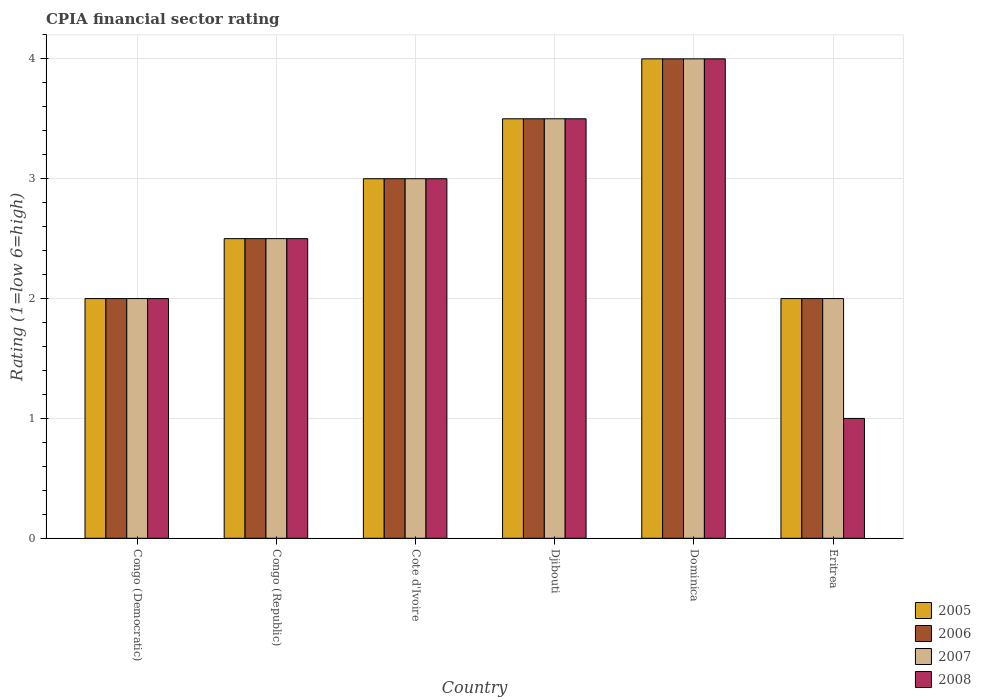How many groups of bars are there?
Your answer should be very brief. 6. Are the number of bars on each tick of the X-axis equal?
Keep it short and to the point. Yes. What is the label of the 6th group of bars from the left?
Your answer should be compact. Eritrea. Across all countries, what is the maximum CPIA rating in 2007?
Make the answer very short. 4. In which country was the CPIA rating in 2006 maximum?
Offer a terse response. Dominica. In which country was the CPIA rating in 2008 minimum?
Provide a succinct answer. Eritrea. What is the total CPIA rating in 2006 in the graph?
Give a very brief answer. 17. What is the difference between the CPIA rating in 2008 in Congo (Republic) and that in Djibouti?
Keep it short and to the point. -1. What is the difference between the CPIA rating in 2006 in Dominica and the CPIA rating in 2007 in Congo (Democratic)?
Your response must be concise. 2. What is the average CPIA rating in 2006 per country?
Offer a terse response. 2.83. In how many countries, is the CPIA rating in 2005 greater than 3.2?
Provide a short and direct response. 2. What is the difference between the highest and the lowest CPIA rating in 2005?
Ensure brevity in your answer.  2. In how many countries, is the CPIA rating in 2005 greater than the average CPIA rating in 2005 taken over all countries?
Offer a terse response. 3. Is the sum of the CPIA rating in 2005 in Congo (Democratic) and Djibouti greater than the maximum CPIA rating in 2007 across all countries?
Your response must be concise. Yes. Is it the case that in every country, the sum of the CPIA rating in 2008 and CPIA rating in 2007 is greater than the sum of CPIA rating in 2005 and CPIA rating in 2006?
Offer a terse response. No. What does the 4th bar from the left in Eritrea represents?
Your answer should be compact. 2008. How many bars are there?
Provide a short and direct response. 24. What is the difference between two consecutive major ticks on the Y-axis?
Provide a short and direct response. 1. Are the values on the major ticks of Y-axis written in scientific E-notation?
Keep it short and to the point. No. Does the graph contain any zero values?
Your response must be concise. No. What is the title of the graph?
Keep it short and to the point. CPIA financial sector rating. Does "1978" appear as one of the legend labels in the graph?
Your response must be concise. No. What is the label or title of the Y-axis?
Offer a terse response. Rating (1=low 6=high). What is the Rating (1=low 6=high) of 2005 in Congo (Democratic)?
Ensure brevity in your answer.  2. What is the Rating (1=low 6=high) of 2006 in Congo (Democratic)?
Offer a very short reply. 2. What is the Rating (1=low 6=high) in 2007 in Congo (Democratic)?
Offer a terse response. 2. What is the Rating (1=low 6=high) in 2008 in Congo (Democratic)?
Ensure brevity in your answer.  2. What is the Rating (1=low 6=high) of 2008 in Congo (Republic)?
Give a very brief answer. 2.5. What is the Rating (1=low 6=high) of 2006 in Cote d'Ivoire?
Give a very brief answer. 3. What is the Rating (1=low 6=high) of 2005 in Djibouti?
Offer a very short reply. 3.5. What is the Rating (1=low 6=high) of 2006 in Djibouti?
Make the answer very short. 3.5. What is the Rating (1=low 6=high) in 2005 in Dominica?
Make the answer very short. 4. What is the Rating (1=low 6=high) in 2006 in Dominica?
Keep it short and to the point. 4. What is the Rating (1=low 6=high) in 2007 in Dominica?
Your answer should be compact. 4. What is the Rating (1=low 6=high) in 2005 in Eritrea?
Give a very brief answer. 2. What is the Rating (1=low 6=high) in 2007 in Eritrea?
Ensure brevity in your answer.  2. Across all countries, what is the maximum Rating (1=low 6=high) of 2005?
Your answer should be compact. 4. Across all countries, what is the maximum Rating (1=low 6=high) in 2006?
Provide a short and direct response. 4. Across all countries, what is the maximum Rating (1=low 6=high) of 2007?
Your answer should be very brief. 4. Across all countries, what is the maximum Rating (1=low 6=high) of 2008?
Give a very brief answer. 4. Across all countries, what is the minimum Rating (1=low 6=high) of 2006?
Keep it short and to the point. 2. Across all countries, what is the minimum Rating (1=low 6=high) in 2008?
Your response must be concise. 1. What is the total Rating (1=low 6=high) of 2006 in the graph?
Your answer should be very brief. 17. What is the total Rating (1=low 6=high) in 2008 in the graph?
Your response must be concise. 16. What is the difference between the Rating (1=low 6=high) of 2005 in Congo (Democratic) and that in Congo (Republic)?
Your answer should be compact. -0.5. What is the difference between the Rating (1=low 6=high) of 2005 in Congo (Democratic) and that in Cote d'Ivoire?
Your answer should be very brief. -1. What is the difference between the Rating (1=low 6=high) of 2006 in Congo (Democratic) and that in Cote d'Ivoire?
Give a very brief answer. -1. What is the difference between the Rating (1=low 6=high) in 2008 in Congo (Democratic) and that in Djibouti?
Provide a short and direct response. -1.5. What is the difference between the Rating (1=low 6=high) in 2008 in Congo (Democratic) and that in Dominica?
Your answer should be very brief. -2. What is the difference between the Rating (1=low 6=high) of 2006 in Congo (Democratic) and that in Eritrea?
Ensure brevity in your answer.  0. What is the difference between the Rating (1=low 6=high) of 2008 in Congo (Democratic) and that in Eritrea?
Give a very brief answer. 1. What is the difference between the Rating (1=low 6=high) in 2005 in Congo (Republic) and that in Cote d'Ivoire?
Your answer should be very brief. -0.5. What is the difference between the Rating (1=low 6=high) in 2006 in Congo (Republic) and that in Cote d'Ivoire?
Your answer should be compact. -0.5. What is the difference between the Rating (1=low 6=high) in 2005 in Congo (Republic) and that in Djibouti?
Offer a terse response. -1. What is the difference between the Rating (1=low 6=high) in 2006 in Congo (Republic) and that in Djibouti?
Keep it short and to the point. -1. What is the difference between the Rating (1=low 6=high) of 2008 in Congo (Republic) and that in Djibouti?
Give a very brief answer. -1. What is the difference between the Rating (1=low 6=high) of 2007 in Congo (Republic) and that in Dominica?
Offer a very short reply. -1.5. What is the difference between the Rating (1=low 6=high) of 2005 in Congo (Republic) and that in Eritrea?
Give a very brief answer. 0.5. What is the difference between the Rating (1=low 6=high) in 2006 in Congo (Republic) and that in Eritrea?
Keep it short and to the point. 0.5. What is the difference between the Rating (1=low 6=high) in 2007 in Cote d'Ivoire and that in Djibouti?
Give a very brief answer. -0.5. What is the difference between the Rating (1=low 6=high) in 2008 in Cote d'Ivoire and that in Djibouti?
Keep it short and to the point. -0.5. What is the difference between the Rating (1=low 6=high) in 2006 in Cote d'Ivoire and that in Dominica?
Provide a short and direct response. -1. What is the difference between the Rating (1=low 6=high) of 2008 in Cote d'Ivoire and that in Eritrea?
Your answer should be compact. 2. What is the difference between the Rating (1=low 6=high) in 2006 in Djibouti and that in Dominica?
Ensure brevity in your answer.  -0.5. What is the difference between the Rating (1=low 6=high) in 2007 in Djibouti and that in Dominica?
Your answer should be very brief. -0.5. What is the difference between the Rating (1=low 6=high) in 2008 in Djibouti and that in Dominica?
Keep it short and to the point. -0.5. What is the difference between the Rating (1=low 6=high) in 2006 in Djibouti and that in Eritrea?
Your answer should be compact. 1.5. What is the difference between the Rating (1=low 6=high) in 2005 in Congo (Democratic) and the Rating (1=low 6=high) in 2006 in Congo (Republic)?
Your response must be concise. -0.5. What is the difference between the Rating (1=low 6=high) of 2005 in Congo (Democratic) and the Rating (1=low 6=high) of 2007 in Congo (Republic)?
Give a very brief answer. -0.5. What is the difference between the Rating (1=low 6=high) in 2005 in Congo (Democratic) and the Rating (1=low 6=high) in 2008 in Congo (Republic)?
Your answer should be compact. -0.5. What is the difference between the Rating (1=low 6=high) in 2006 in Congo (Democratic) and the Rating (1=low 6=high) in 2007 in Congo (Republic)?
Make the answer very short. -0.5. What is the difference between the Rating (1=low 6=high) in 2007 in Congo (Democratic) and the Rating (1=low 6=high) in 2008 in Congo (Republic)?
Keep it short and to the point. -0.5. What is the difference between the Rating (1=low 6=high) of 2005 in Congo (Democratic) and the Rating (1=low 6=high) of 2006 in Cote d'Ivoire?
Give a very brief answer. -1. What is the difference between the Rating (1=low 6=high) in 2005 in Congo (Democratic) and the Rating (1=low 6=high) in 2007 in Cote d'Ivoire?
Offer a very short reply. -1. What is the difference between the Rating (1=low 6=high) of 2005 in Congo (Democratic) and the Rating (1=low 6=high) of 2008 in Cote d'Ivoire?
Make the answer very short. -1. What is the difference between the Rating (1=low 6=high) in 2006 in Congo (Democratic) and the Rating (1=low 6=high) in 2007 in Cote d'Ivoire?
Give a very brief answer. -1. What is the difference between the Rating (1=low 6=high) of 2006 in Congo (Democratic) and the Rating (1=low 6=high) of 2008 in Cote d'Ivoire?
Offer a terse response. -1. What is the difference between the Rating (1=low 6=high) in 2005 in Congo (Democratic) and the Rating (1=low 6=high) in 2007 in Djibouti?
Keep it short and to the point. -1.5. What is the difference between the Rating (1=low 6=high) in 2006 in Congo (Democratic) and the Rating (1=low 6=high) in 2007 in Djibouti?
Offer a terse response. -1.5. What is the difference between the Rating (1=low 6=high) in 2007 in Congo (Democratic) and the Rating (1=low 6=high) in 2008 in Djibouti?
Make the answer very short. -1.5. What is the difference between the Rating (1=low 6=high) of 2005 in Congo (Democratic) and the Rating (1=low 6=high) of 2008 in Dominica?
Make the answer very short. -2. What is the difference between the Rating (1=low 6=high) of 2006 in Congo (Democratic) and the Rating (1=low 6=high) of 2007 in Dominica?
Offer a terse response. -2. What is the difference between the Rating (1=low 6=high) in 2007 in Congo (Democratic) and the Rating (1=low 6=high) in 2008 in Dominica?
Offer a very short reply. -2. What is the difference between the Rating (1=low 6=high) of 2005 in Congo (Democratic) and the Rating (1=low 6=high) of 2008 in Eritrea?
Provide a short and direct response. 1. What is the difference between the Rating (1=low 6=high) of 2007 in Congo (Democratic) and the Rating (1=low 6=high) of 2008 in Eritrea?
Provide a short and direct response. 1. What is the difference between the Rating (1=low 6=high) of 2005 in Congo (Republic) and the Rating (1=low 6=high) of 2006 in Cote d'Ivoire?
Your response must be concise. -0.5. What is the difference between the Rating (1=low 6=high) of 2005 in Congo (Republic) and the Rating (1=low 6=high) of 2007 in Cote d'Ivoire?
Keep it short and to the point. -0.5. What is the difference between the Rating (1=low 6=high) of 2005 in Congo (Republic) and the Rating (1=low 6=high) of 2008 in Cote d'Ivoire?
Provide a succinct answer. -0.5. What is the difference between the Rating (1=low 6=high) in 2006 in Congo (Republic) and the Rating (1=low 6=high) in 2008 in Cote d'Ivoire?
Offer a very short reply. -0.5. What is the difference between the Rating (1=low 6=high) in 2007 in Congo (Republic) and the Rating (1=low 6=high) in 2008 in Cote d'Ivoire?
Your response must be concise. -0.5. What is the difference between the Rating (1=low 6=high) of 2005 in Congo (Republic) and the Rating (1=low 6=high) of 2006 in Djibouti?
Ensure brevity in your answer.  -1. What is the difference between the Rating (1=low 6=high) of 2005 in Congo (Republic) and the Rating (1=low 6=high) of 2007 in Djibouti?
Offer a very short reply. -1. What is the difference between the Rating (1=low 6=high) of 2006 in Congo (Republic) and the Rating (1=low 6=high) of 2007 in Djibouti?
Your response must be concise. -1. What is the difference between the Rating (1=low 6=high) of 2006 in Congo (Republic) and the Rating (1=low 6=high) of 2008 in Djibouti?
Offer a very short reply. -1. What is the difference between the Rating (1=low 6=high) of 2007 in Congo (Republic) and the Rating (1=low 6=high) of 2008 in Djibouti?
Your answer should be compact. -1. What is the difference between the Rating (1=low 6=high) of 2005 in Congo (Republic) and the Rating (1=low 6=high) of 2006 in Dominica?
Your response must be concise. -1.5. What is the difference between the Rating (1=low 6=high) in 2005 in Congo (Republic) and the Rating (1=low 6=high) in 2007 in Dominica?
Offer a terse response. -1.5. What is the difference between the Rating (1=low 6=high) in 2005 in Congo (Republic) and the Rating (1=low 6=high) in 2008 in Dominica?
Your answer should be very brief. -1.5. What is the difference between the Rating (1=low 6=high) in 2006 in Congo (Republic) and the Rating (1=low 6=high) in 2007 in Dominica?
Give a very brief answer. -1.5. What is the difference between the Rating (1=low 6=high) of 2006 in Congo (Republic) and the Rating (1=low 6=high) of 2008 in Dominica?
Offer a terse response. -1.5. What is the difference between the Rating (1=low 6=high) of 2005 in Congo (Republic) and the Rating (1=low 6=high) of 2008 in Eritrea?
Your answer should be very brief. 1.5. What is the difference between the Rating (1=low 6=high) of 2006 in Congo (Republic) and the Rating (1=low 6=high) of 2007 in Eritrea?
Your answer should be compact. 0.5. What is the difference between the Rating (1=low 6=high) in 2005 in Cote d'Ivoire and the Rating (1=low 6=high) in 2006 in Djibouti?
Your answer should be compact. -0.5. What is the difference between the Rating (1=low 6=high) of 2005 in Cote d'Ivoire and the Rating (1=low 6=high) of 2007 in Djibouti?
Make the answer very short. -0.5. What is the difference between the Rating (1=low 6=high) in 2005 in Cote d'Ivoire and the Rating (1=low 6=high) in 2007 in Dominica?
Offer a terse response. -1. What is the difference between the Rating (1=low 6=high) in 2005 in Cote d'Ivoire and the Rating (1=low 6=high) in 2008 in Dominica?
Make the answer very short. -1. What is the difference between the Rating (1=low 6=high) of 2006 in Cote d'Ivoire and the Rating (1=low 6=high) of 2008 in Dominica?
Give a very brief answer. -1. What is the difference between the Rating (1=low 6=high) in 2005 in Cote d'Ivoire and the Rating (1=low 6=high) in 2006 in Eritrea?
Keep it short and to the point. 1. What is the difference between the Rating (1=low 6=high) in 2005 in Cote d'Ivoire and the Rating (1=low 6=high) in 2008 in Eritrea?
Offer a terse response. 2. What is the difference between the Rating (1=low 6=high) in 2006 in Cote d'Ivoire and the Rating (1=low 6=high) in 2007 in Eritrea?
Ensure brevity in your answer.  1. What is the difference between the Rating (1=low 6=high) in 2005 in Djibouti and the Rating (1=low 6=high) in 2007 in Dominica?
Offer a terse response. -0.5. What is the difference between the Rating (1=low 6=high) of 2005 in Djibouti and the Rating (1=low 6=high) of 2008 in Dominica?
Provide a succinct answer. -0.5. What is the difference between the Rating (1=low 6=high) of 2006 in Djibouti and the Rating (1=low 6=high) of 2007 in Dominica?
Give a very brief answer. -0.5. What is the difference between the Rating (1=low 6=high) of 2006 in Djibouti and the Rating (1=low 6=high) of 2008 in Dominica?
Your answer should be very brief. -0.5. What is the difference between the Rating (1=low 6=high) in 2007 in Djibouti and the Rating (1=low 6=high) in 2008 in Dominica?
Provide a succinct answer. -0.5. What is the difference between the Rating (1=low 6=high) in 2005 in Djibouti and the Rating (1=low 6=high) in 2008 in Eritrea?
Your response must be concise. 2.5. What is the difference between the Rating (1=low 6=high) in 2006 in Djibouti and the Rating (1=low 6=high) in 2008 in Eritrea?
Keep it short and to the point. 2.5. What is the difference between the Rating (1=low 6=high) of 2005 in Dominica and the Rating (1=low 6=high) of 2007 in Eritrea?
Make the answer very short. 2. What is the difference between the Rating (1=low 6=high) of 2006 in Dominica and the Rating (1=low 6=high) of 2007 in Eritrea?
Make the answer very short. 2. What is the average Rating (1=low 6=high) in 2005 per country?
Offer a terse response. 2.83. What is the average Rating (1=low 6=high) in 2006 per country?
Keep it short and to the point. 2.83. What is the average Rating (1=low 6=high) of 2007 per country?
Keep it short and to the point. 2.83. What is the average Rating (1=low 6=high) of 2008 per country?
Your answer should be very brief. 2.67. What is the difference between the Rating (1=low 6=high) of 2005 and Rating (1=low 6=high) of 2007 in Congo (Democratic)?
Your response must be concise. 0. What is the difference between the Rating (1=low 6=high) in 2006 and Rating (1=low 6=high) in 2007 in Congo (Democratic)?
Make the answer very short. 0. What is the difference between the Rating (1=low 6=high) of 2005 and Rating (1=low 6=high) of 2007 in Congo (Republic)?
Offer a very short reply. 0. What is the difference between the Rating (1=low 6=high) in 2005 and Rating (1=low 6=high) in 2008 in Cote d'Ivoire?
Your response must be concise. 0. What is the difference between the Rating (1=low 6=high) of 2006 and Rating (1=low 6=high) of 2007 in Cote d'Ivoire?
Keep it short and to the point. 0. What is the difference between the Rating (1=low 6=high) of 2006 and Rating (1=low 6=high) of 2008 in Cote d'Ivoire?
Offer a very short reply. 0. What is the difference between the Rating (1=low 6=high) of 2007 and Rating (1=low 6=high) of 2008 in Cote d'Ivoire?
Offer a terse response. 0. What is the difference between the Rating (1=low 6=high) of 2005 and Rating (1=low 6=high) of 2006 in Djibouti?
Offer a very short reply. 0. What is the difference between the Rating (1=low 6=high) of 2005 and Rating (1=low 6=high) of 2007 in Djibouti?
Provide a short and direct response. 0. What is the difference between the Rating (1=low 6=high) of 2006 and Rating (1=low 6=high) of 2008 in Djibouti?
Keep it short and to the point. 0. What is the difference between the Rating (1=low 6=high) in 2007 and Rating (1=low 6=high) in 2008 in Djibouti?
Provide a succinct answer. 0. What is the difference between the Rating (1=low 6=high) in 2005 and Rating (1=low 6=high) in 2006 in Dominica?
Give a very brief answer. 0. What is the difference between the Rating (1=low 6=high) of 2006 and Rating (1=low 6=high) of 2008 in Dominica?
Ensure brevity in your answer.  0. What is the difference between the Rating (1=low 6=high) in 2007 and Rating (1=low 6=high) in 2008 in Dominica?
Ensure brevity in your answer.  0. What is the difference between the Rating (1=low 6=high) of 2005 and Rating (1=low 6=high) of 2008 in Eritrea?
Ensure brevity in your answer.  1. What is the difference between the Rating (1=low 6=high) of 2006 and Rating (1=low 6=high) of 2007 in Eritrea?
Offer a terse response. 0. What is the ratio of the Rating (1=low 6=high) of 2005 in Congo (Democratic) to that in Congo (Republic)?
Provide a short and direct response. 0.8. What is the ratio of the Rating (1=low 6=high) in 2007 in Congo (Democratic) to that in Congo (Republic)?
Make the answer very short. 0.8. What is the ratio of the Rating (1=low 6=high) of 2008 in Congo (Democratic) to that in Congo (Republic)?
Offer a terse response. 0.8. What is the ratio of the Rating (1=low 6=high) of 2007 in Congo (Democratic) to that in Cote d'Ivoire?
Make the answer very short. 0.67. What is the ratio of the Rating (1=low 6=high) in 2008 in Congo (Democratic) to that in Cote d'Ivoire?
Your response must be concise. 0.67. What is the ratio of the Rating (1=low 6=high) in 2005 in Congo (Democratic) to that in Dominica?
Give a very brief answer. 0.5. What is the ratio of the Rating (1=low 6=high) in 2006 in Congo (Democratic) to that in Dominica?
Give a very brief answer. 0.5. What is the ratio of the Rating (1=low 6=high) of 2007 in Congo (Democratic) to that in Dominica?
Keep it short and to the point. 0.5. What is the ratio of the Rating (1=low 6=high) of 2008 in Congo (Democratic) to that in Dominica?
Your answer should be compact. 0.5. What is the ratio of the Rating (1=low 6=high) of 2006 in Congo (Democratic) to that in Eritrea?
Provide a short and direct response. 1. What is the ratio of the Rating (1=low 6=high) of 2007 in Congo (Democratic) to that in Eritrea?
Keep it short and to the point. 1. What is the ratio of the Rating (1=low 6=high) in 2008 in Congo (Democratic) to that in Eritrea?
Your answer should be compact. 2. What is the ratio of the Rating (1=low 6=high) of 2005 in Congo (Republic) to that in Djibouti?
Your answer should be very brief. 0.71. What is the ratio of the Rating (1=low 6=high) in 2006 in Congo (Republic) to that in Djibouti?
Your answer should be very brief. 0.71. What is the ratio of the Rating (1=low 6=high) of 2005 in Congo (Republic) to that in Dominica?
Ensure brevity in your answer.  0.62. What is the ratio of the Rating (1=low 6=high) in 2006 in Congo (Republic) to that in Dominica?
Your answer should be compact. 0.62. What is the ratio of the Rating (1=low 6=high) in 2007 in Congo (Republic) to that in Dominica?
Provide a succinct answer. 0.62. What is the ratio of the Rating (1=low 6=high) of 2008 in Congo (Republic) to that in Dominica?
Make the answer very short. 0.62. What is the ratio of the Rating (1=low 6=high) in 2005 in Congo (Republic) to that in Eritrea?
Make the answer very short. 1.25. What is the ratio of the Rating (1=low 6=high) of 2008 in Congo (Republic) to that in Eritrea?
Ensure brevity in your answer.  2.5. What is the ratio of the Rating (1=low 6=high) in 2006 in Cote d'Ivoire to that in Dominica?
Ensure brevity in your answer.  0.75. What is the ratio of the Rating (1=low 6=high) in 2007 in Cote d'Ivoire to that in Dominica?
Offer a terse response. 0.75. What is the ratio of the Rating (1=low 6=high) in 2008 in Cote d'Ivoire to that in Eritrea?
Offer a terse response. 3. What is the ratio of the Rating (1=low 6=high) in 2005 in Djibouti to that in Dominica?
Offer a very short reply. 0.88. What is the ratio of the Rating (1=low 6=high) of 2007 in Djibouti to that in Dominica?
Your answer should be very brief. 0.88. What is the ratio of the Rating (1=low 6=high) of 2008 in Djibouti to that in Dominica?
Keep it short and to the point. 0.88. What is the ratio of the Rating (1=low 6=high) of 2008 in Djibouti to that in Eritrea?
Keep it short and to the point. 3.5. What is the ratio of the Rating (1=low 6=high) in 2006 in Dominica to that in Eritrea?
Offer a very short reply. 2. What is the ratio of the Rating (1=low 6=high) in 2007 in Dominica to that in Eritrea?
Your answer should be very brief. 2. What is the difference between the highest and the second highest Rating (1=low 6=high) of 2005?
Your response must be concise. 0.5. What is the difference between the highest and the second highest Rating (1=low 6=high) of 2006?
Give a very brief answer. 0.5. What is the difference between the highest and the second highest Rating (1=low 6=high) in 2008?
Ensure brevity in your answer.  0.5. What is the difference between the highest and the lowest Rating (1=low 6=high) in 2005?
Offer a terse response. 2. What is the difference between the highest and the lowest Rating (1=low 6=high) in 2006?
Your answer should be very brief. 2. What is the difference between the highest and the lowest Rating (1=low 6=high) of 2008?
Give a very brief answer. 3. 